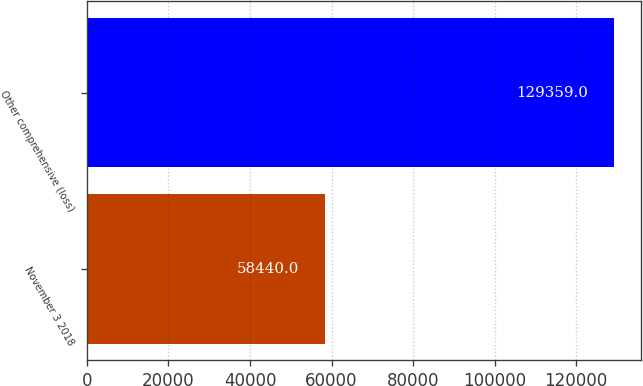<chart> <loc_0><loc_0><loc_500><loc_500><bar_chart><fcel>November 3 2018<fcel>Other comprehensive (loss)<nl><fcel>58440<fcel>129359<nl></chart> 